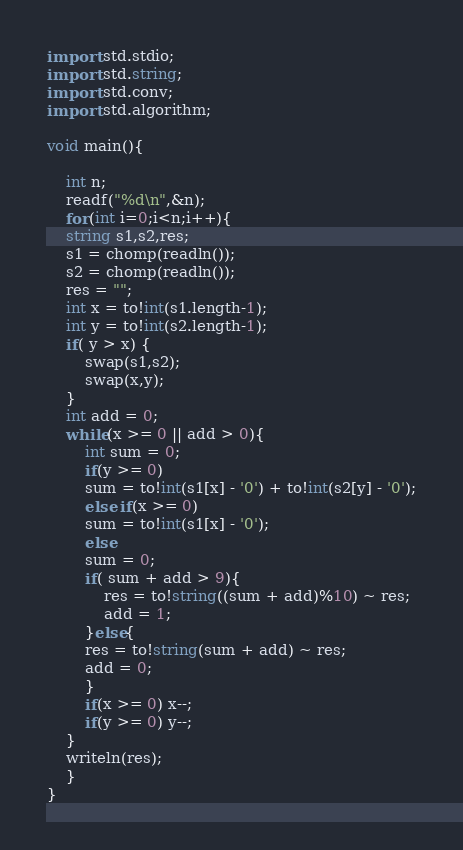<code> <loc_0><loc_0><loc_500><loc_500><_D_>import std.stdio;
import std.string;
import std.conv;
import std.algorithm;

void main(){

    int n;
    readf("%d\n",&n);
    for(int i=0;i<n;i++){
	string s1,s2,res;
	s1 = chomp(readln());
	s2 = chomp(readln());
	res = "";
	int x = to!int(s1.length-1);
	int y = to!int(s2.length-1);
	if( y > x) {
	    swap(s1,s2);
	    swap(x,y);
	}
	int add = 0;
	while(x >= 0 || add > 0){
	    int sum = 0;
	    if(y >= 0)
		sum = to!int(s1[x] - '0') + to!int(s2[y] - '0');
	    else if(x >= 0)
		sum = to!int(s1[x] - '0');
	    else 
		sum = 0;
	    if( sum + add > 9){
		    res = to!string((sum + add)%10) ~ res;
		    add = 1;
	    }else{
		res = to!string(sum + add) ~ res;
		add = 0;
	    }
	    if(x >= 0) x--;
	    if(y >= 0) y--;
	}
	writeln(res);
    }
}</code> 